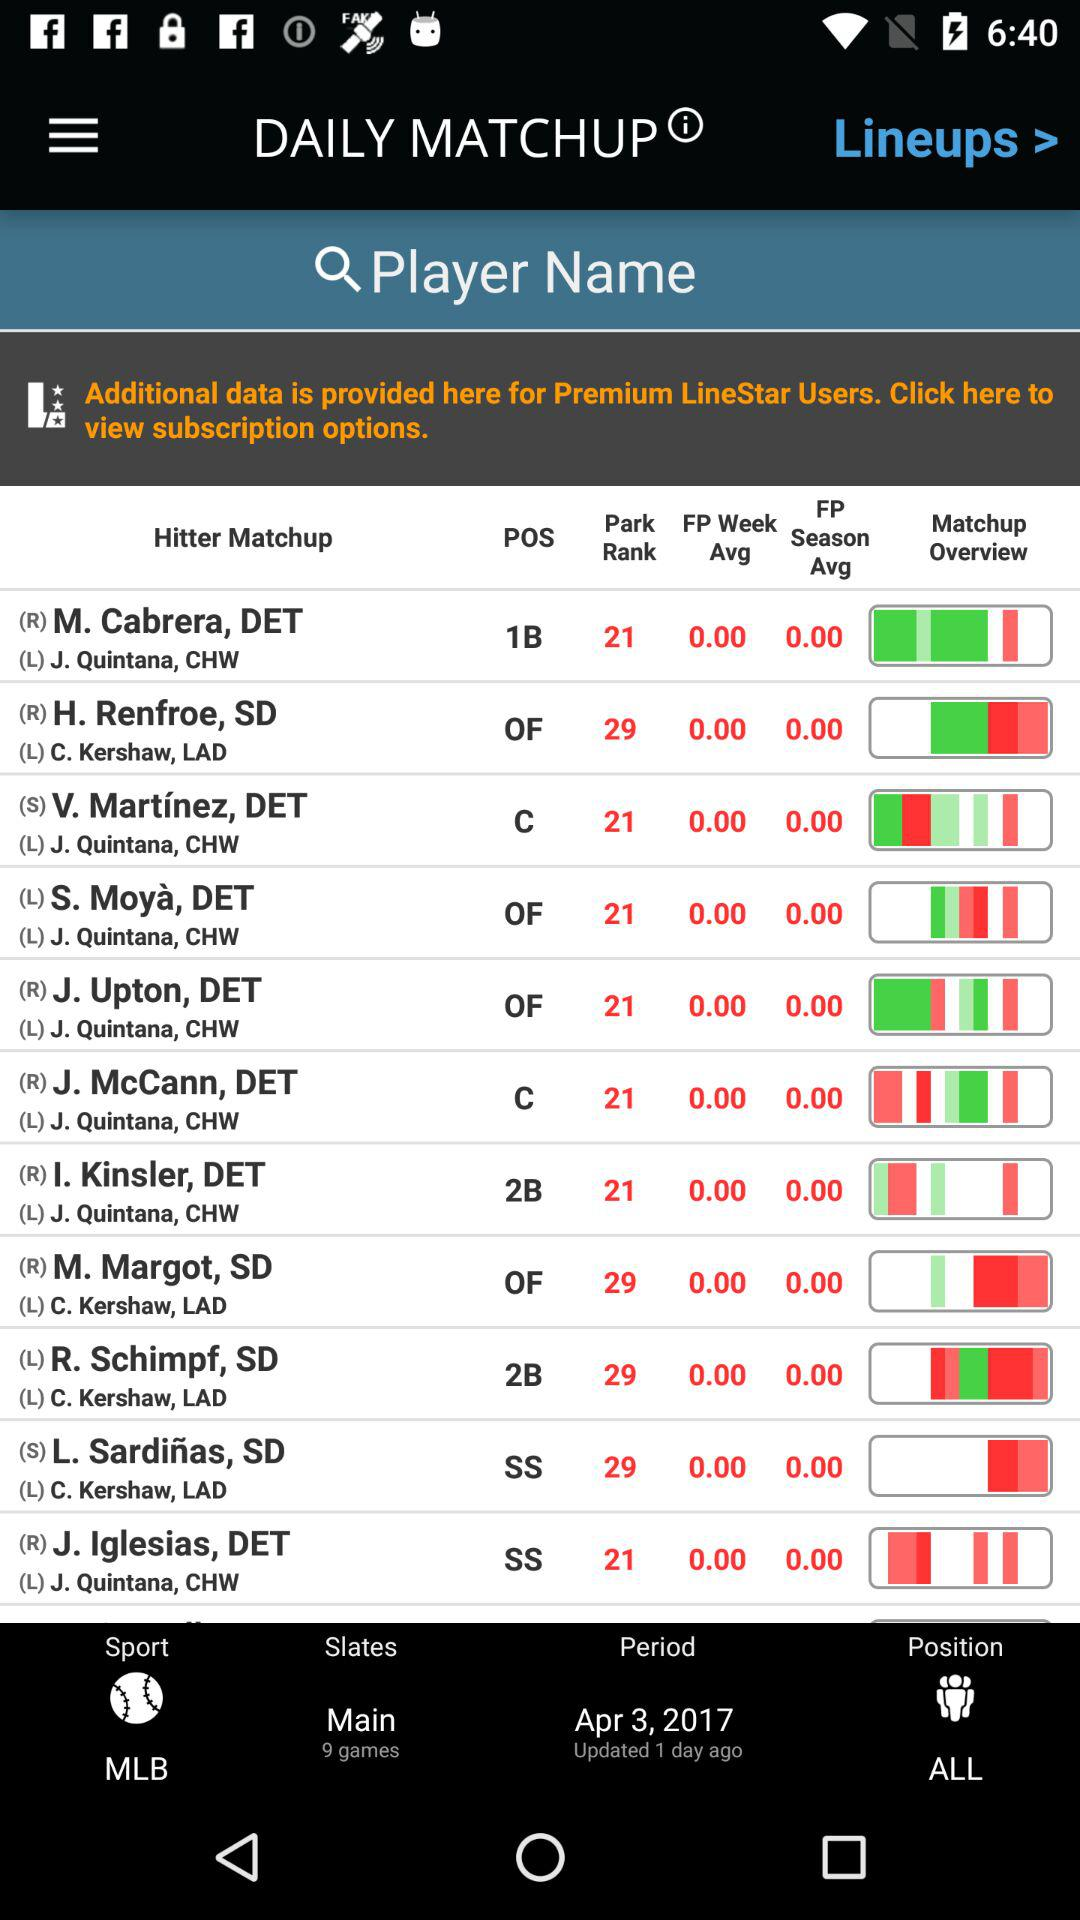Which player has the highest rank?
When the provided information is insufficient, respond with <no answer>. <no answer> 